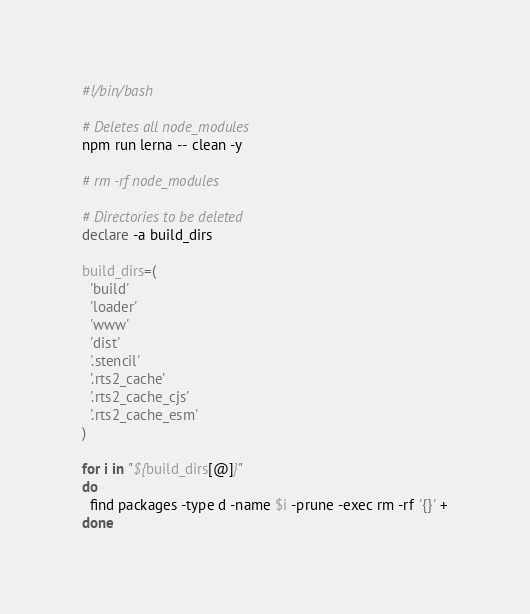Convert code to text. <code><loc_0><loc_0><loc_500><loc_500><_Bash_>#!/bin/bash

# Deletes all node_modules
npm run lerna -- clean -y

# rm -rf node_modules

# Directories to be deleted
declare -a build_dirs

build_dirs=(
  'build'
  'loader'
  'www'
  'dist'
  '.stencil'
  '.rts2_cache'
  '.rts2_cache_cjs'
  '.rts2_cache_esm'
)

for i in "${build_dirs[@]}"
do
  find packages -type d -name $i -prune -exec rm -rf '{}' +
done
</code> 